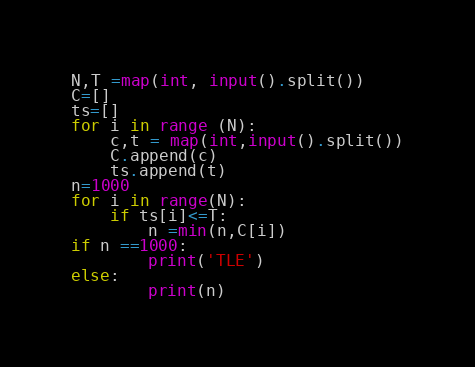<code> <loc_0><loc_0><loc_500><loc_500><_Python_>N,T =map(int, input().split())
C=[]
ts=[]
for i in range (N):
    c,t = map(int,input().split())
    C.append(c)
    ts.append(t)
n=1000
for i in range(N):
    if ts[i]<=T:
        n =min(n,C[i])
if n ==1000:
        print('TLE')
else:
        print(n)</code> 